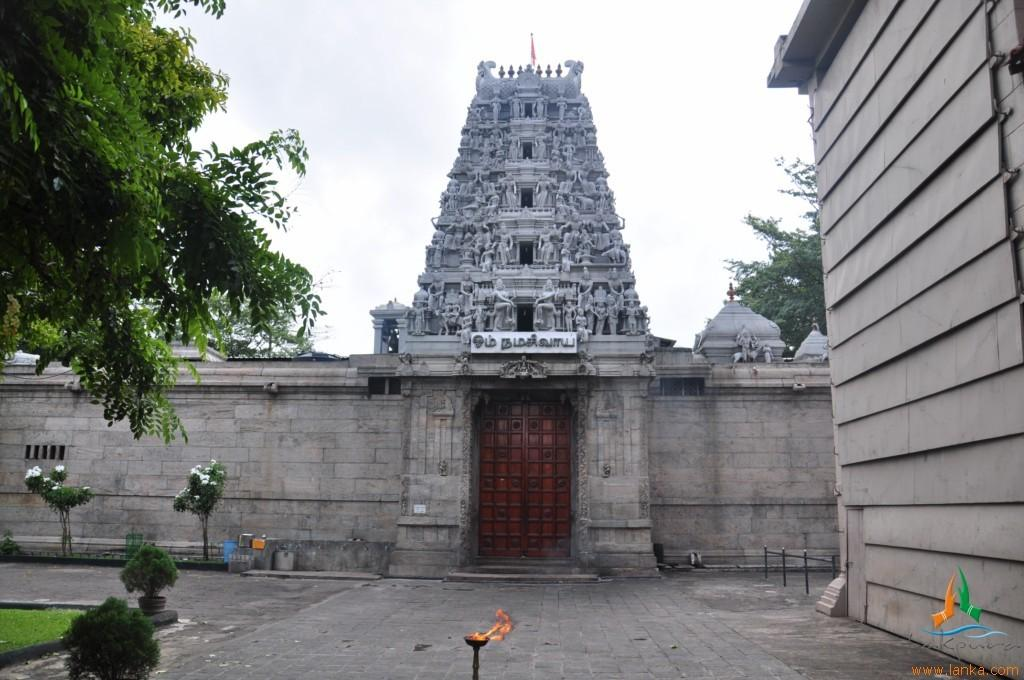What is the main structure in the center of the image? There is a temple in the center of the image. What feature can be found on the temple? There is a door in the temple. What is located on the right side of the image? There is a wall on the right side of the image. What type of vegetation is on the left side of the image? There are trees and plants on the left side of the image. What can be seen in the background of the image? The sky is visible in the background of the image. What type of card is being used to play a game in the image? There is no card or game present in the image; it features a temple with a door and surrounding vegetation. What emotion is being displayed by the temple in the image? The temple is an inanimate object and does not display emotions like disgust. 